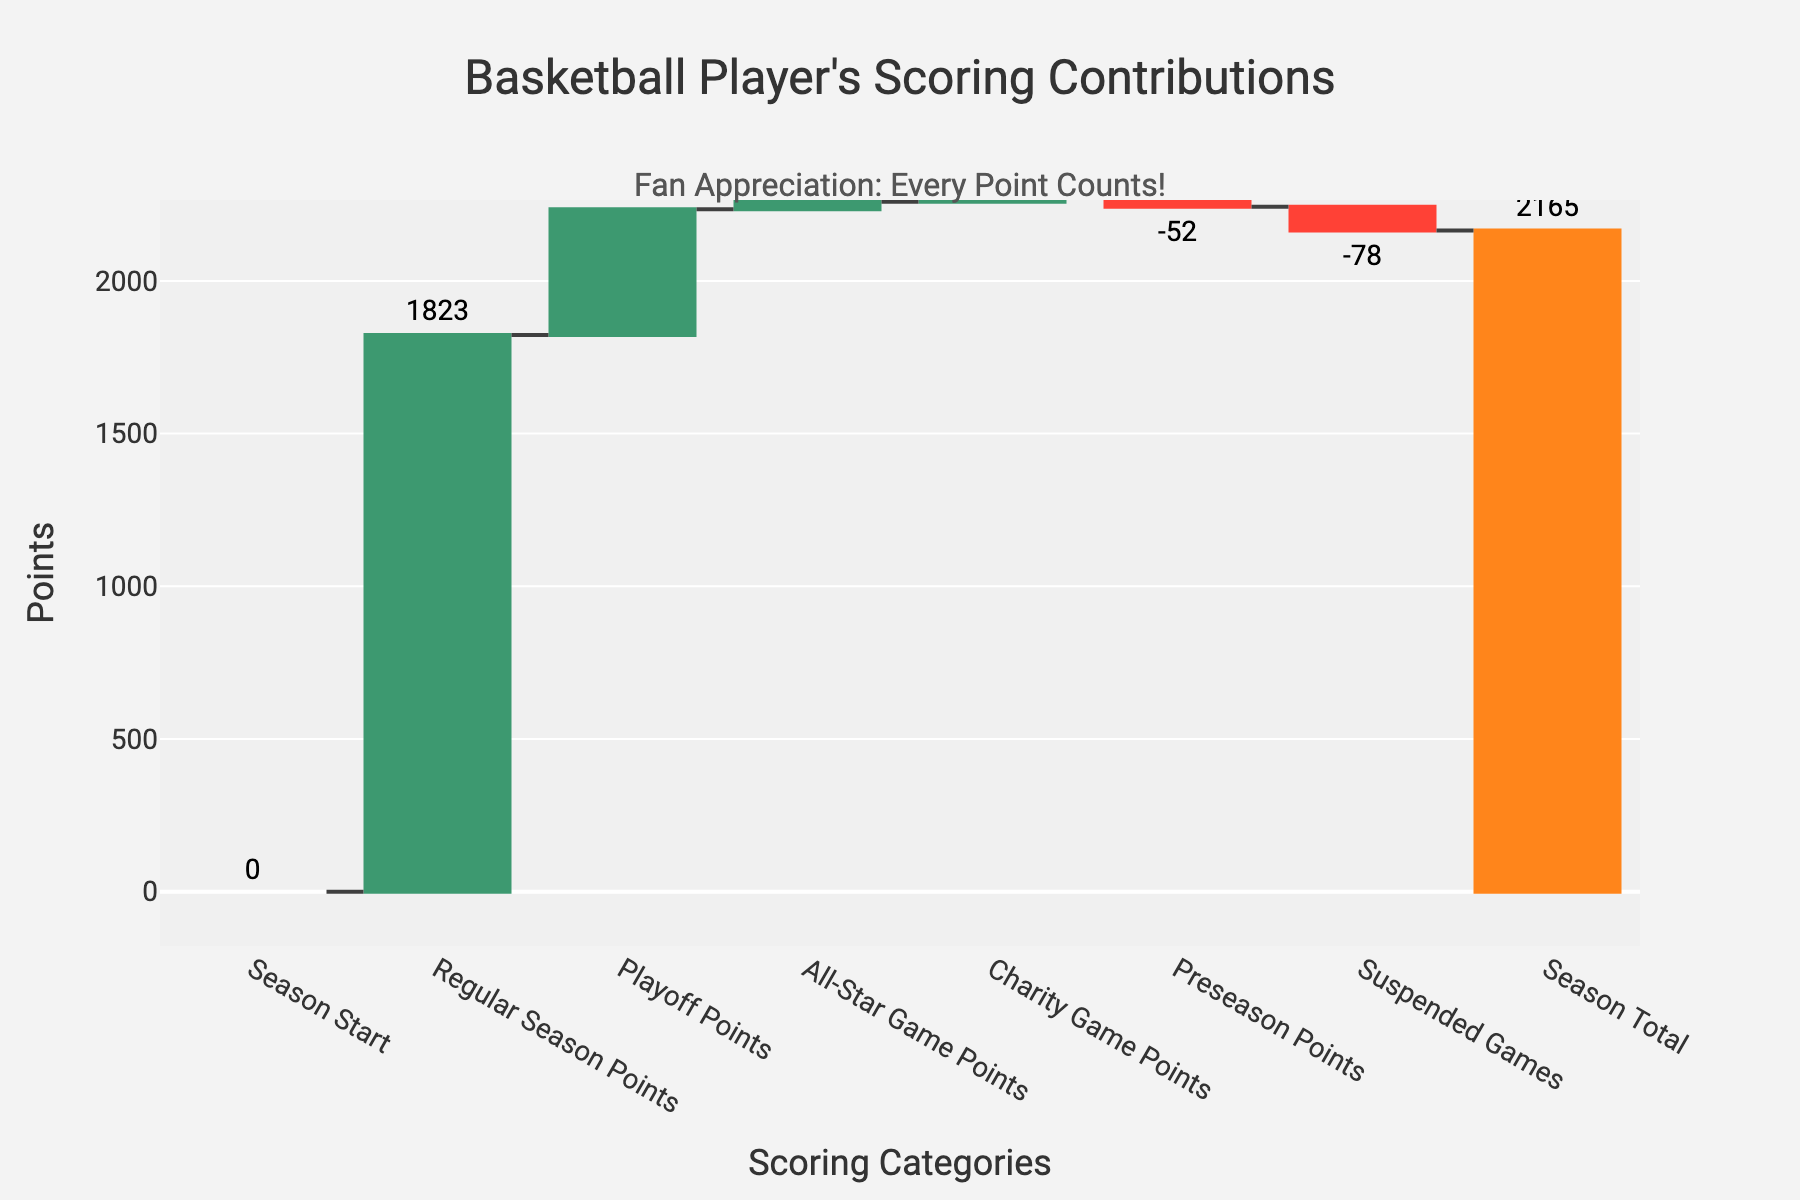What is the title of the chart? The title is displayed at the top center of the chart and it is written in relatively large font size.
Answer: Basketball Player's Scoring Contributions What does the "Season Total" value indicate? The "Season Total" value is the cumulative points, considering all other categories' contributions upwards and downwards.
Answer: 2165 How many categories contributed to the player's scoring? Count the number of unique categories listed along the x-axis of the waterfall chart, including the "Season Total".
Answer: 7 Comparing 'Regular Season Points' and 'Playoff Points', which one is higher? Observe the lengths of the bars in the vertical direction and the exact values displayed above them. The longer bar indicates a higher value.
Answer: Regular Season Points What is the difference between 'Regular Season Points' and 'Preseason Points'? Find the values of each, then subtract the 'Preseason Points' from the 'Regular Season Points'.
Answer: 1875 How much did the 'Suspended Games' reduce the total points by? Identify the negative values along the y-axis, specifically noting the 'Suspended Games' bar length.
Answer: 78 What is the combined point total of 'All-Star Game Points' and 'Charity Game Points'? Locate these two categories' values and sum them up.
Answer: 60 Which category had the least contribution to the total points? Compare the values of all categories to find the smallest value.
Answer: Preseason Points How did the 'Charity Game Points' impact the total score? Note that the 'Charity Game Points' shows an increase in the visual depiction and identify how much it added to the total.
Answer: Added 36 If 'Regular Season Points' were 50 points lower, what would the new 'Season Total' be? Subtract 50 from the 'Regular Season Points' and then adjust the 'Season Total' likewise. Calculate the new 'Season Total' accordingly.
Answer: 2115 